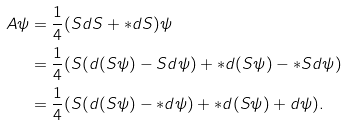<formula> <loc_0><loc_0><loc_500><loc_500>A \psi & = \frac { 1 } { 4 } ( S d S + * d S ) \psi \\ & = \frac { 1 } { 4 } ( S ( d ( S \psi ) - S d \psi ) + * d ( S \psi ) - * S d \psi ) \\ & = \frac { 1 } { 4 } ( S ( d ( S \psi ) - * d \psi ) + * d ( S \psi ) + d \psi ) .</formula> 